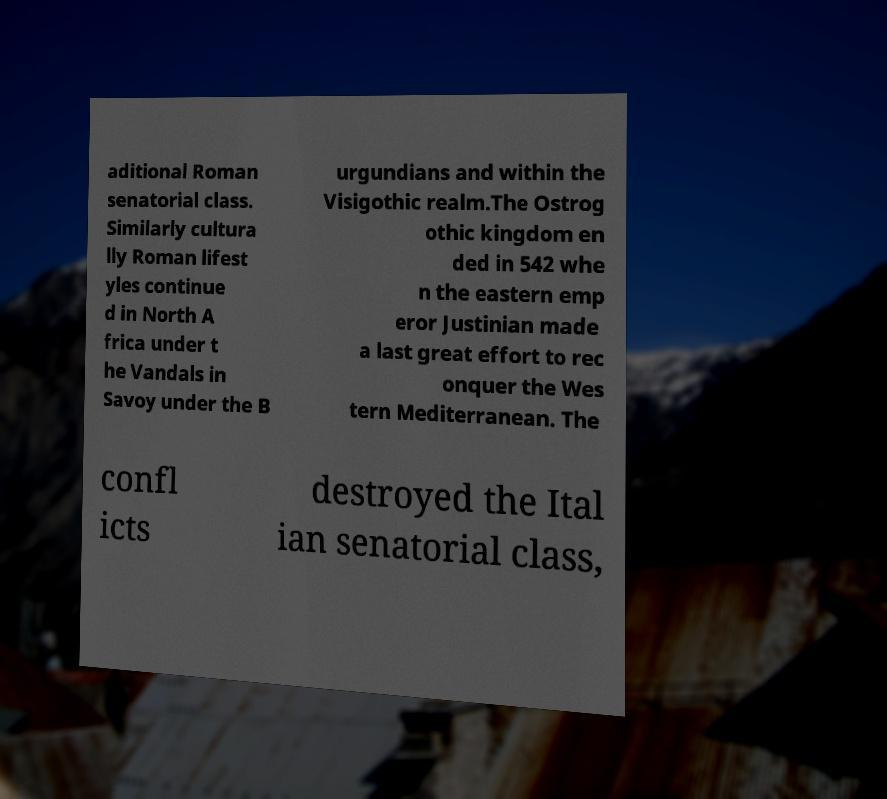For documentation purposes, I need the text within this image transcribed. Could you provide that? aditional Roman senatorial class. Similarly cultura lly Roman lifest yles continue d in North A frica under t he Vandals in Savoy under the B urgundians and within the Visigothic realm.The Ostrog othic kingdom en ded in 542 whe n the eastern emp eror Justinian made a last great effort to rec onquer the Wes tern Mediterranean. The confl icts destroyed the Ital ian senatorial class, 